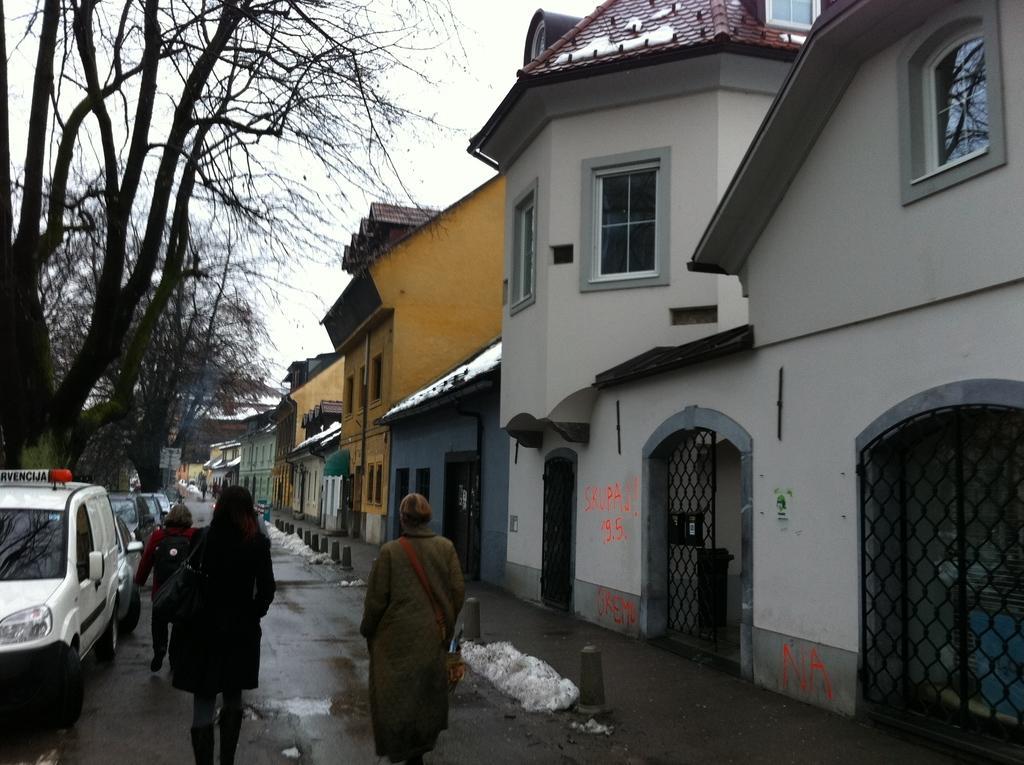Please provide a concise description of this image. In this picture I can see buildings and few cars on the road and I can see few people walking and I can see trees and looks like snow on the ground and on the buildings and I can see cloudy sky. 